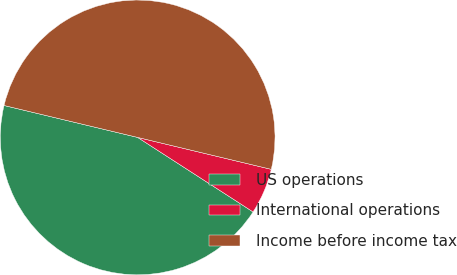Convert chart. <chart><loc_0><loc_0><loc_500><loc_500><pie_chart><fcel>US operations<fcel>International operations<fcel>Income before income tax<nl><fcel>44.61%<fcel>5.39%<fcel>50.0%<nl></chart> 